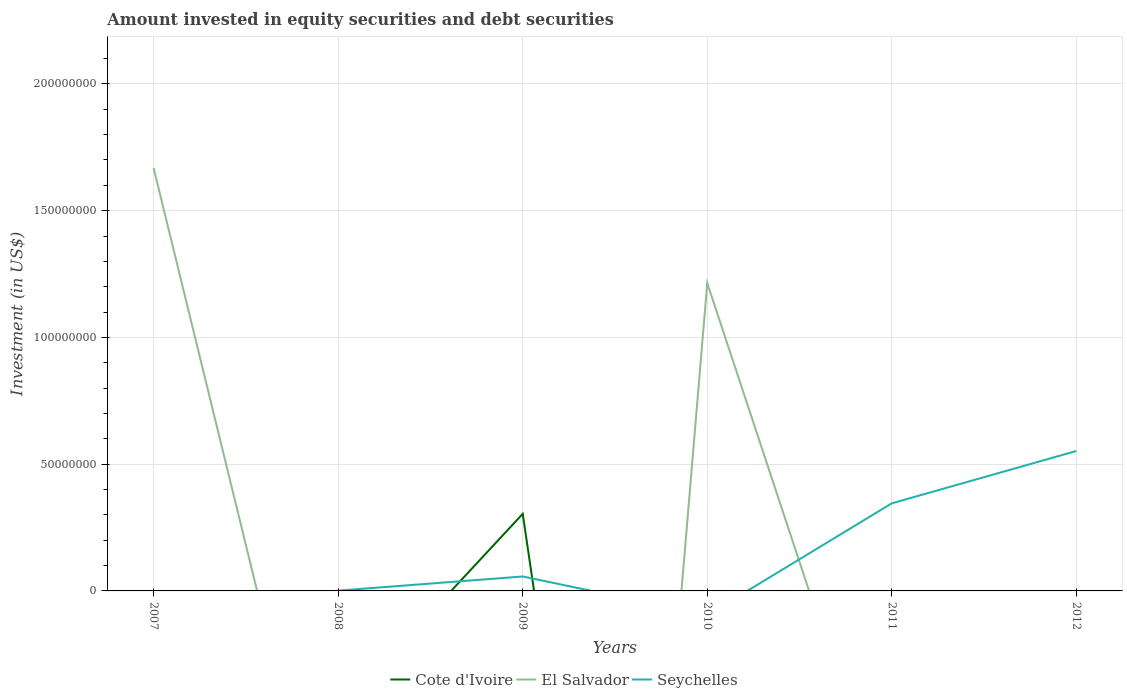How many different coloured lines are there?
Offer a very short reply. 3. Is the number of lines equal to the number of legend labels?
Give a very brief answer. No. Across all years, what is the maximum amount invested in equity securities and debt securities in Seychelles?
Ensure brevity in your answer.  0. What is the total amount invested in equity securities and debt securities in Seychelles in the graph?
Offer a terse response. -5.58e+06. What is the difference between the highest and the second highest amount invested in equity securities and debt securities in Cote d'Ivoire?
Keep it short and to the point. 3.04e+07. Is the amount invested in equity securities and debt securities in Cote d'Ivoire strictly greater than the amount invested in equity securities and debt securities in Seychelles over the years?
Your answer should be compact. No. How many years are there in the graph?
Offer a very short reply. 6. Are the values on the major ticks of Y-axis written in scientific E-notation?
Your answer should be compact. No. Where does the legend appear in the graph?
Provide a succinct answer. Bottom center. How are the legend labels stacked?
Ensure brevity in your answer.  Horizontal. What is the title of the graph?
Your answer should be very brief. Amount invested in equity securities and debt securities. What is the label or title of the Y-axis?
Give a very brief answer. Investment (in US$). What is the Investment (in US$) in El Salvador in 2007?
Offer a very short reply. 1.67e+08. What is the Investment (in US$) in Cote d'Ivoire in 2008?
Make the answer very short. 0. What is the Investment (in US$) in Seychelles in 2008?
Your response must be concise. 1.16e+05. What is the Investment (in US$) in Cote d'Ivoire in 2009?
Your answer should be very brief. 3.04e+07. What is the Investment (in US$) of Seychelles in 2009?
Your answer should be compact. 5.70e+06. What is the Investment (in US$) of El Salvador in 2010?
Offer a very short reply. 1.21e+08. What is the Investment (in US$) of Seychelles in 2010?
Offer a very short reply. 0. What is the Investment (in US$) of El Salvador in 2011?
Provide a succinct answer. 0. What is the Investment (in US$) of Seychelles in 2011?
Give a very brief answer. 3.46e+07. What is the Investment (in US$) in Cote d'Ivoire in 2012?
Keep it short and to the point. 0. What is the Investment (in US$) of El Salvador in 2012?
Make the answer very short. 0. What is the Investment (in US$) in Seychelles in 2012?
Your answer should be compact. 5.52e+07. Across all years, what is the maximum Investment (in US$) in Cote d'Ivoire?
Provide a succinct answer. 3.04e+07. Across all years, what is the maximum Investment (in US$) of El Salvador?
Offer a very short reply. 1.67e+08. Across all years, what is the maximum Investment (in US$) in Seychelles?
Provide a short and direct response. 5.52e+07. Across all years, what is the minimum Investment (in US$) of Cote d'Ivoire?
Offer a very short reply. 0. What is the total Investment (in US$) in Cote d'Ivoire in the graph?
Your response must be concise. 3.04e+07. What is the total Investment (in US$) in El Salvador in the graph?
Make the answer very short. 2.88e+08. What is the total Investment (in US$) in Seychelles in the graph?
Give a very brief answer. 9.56e+07. What is the difference between the Investment (in US$) of El Salvador in 2007 and that in 2010?
Keep it short and to the point. 4.54e+07. What is the difference between the Investment (in US$) in Seychelles in 2008 and that in 2009?
Give a very brief answer. -5.58e+06. What is the difference between the Investment (in US$) in Seychelles in 2008 and that in 2011?
Ensure brevity in your answer.  -3.44e+07. What is the difference between the Investment (in US$) of Seychelles in 2008 and that in 2012?
Offer a very short reply. -5.51e+07. What is the difference between the Investment (in US$) of Seychelles in 2009 and that in 2011?
Your answer should be very brief. -2.89e+07. What is the difference between the Investment (in US$) in Seychelles in 2009 and that in 2012?
Your answer should be compact. -4.95e+07. What is the difference between the Investment (in US$) in Seychelles in 2011 and that in 2012?
Your answer should be compact. -2.07e+07. What is the difference between the Investment (in US$) in El Salvador in 2007 and the Investment (in US$) in Seychelles in 2008?
Your response must be concise. 1.67e+08. What is the difference between the Investment (in US$) of El Salvador in 2007 and the Investment (in US$) of Seychelles in 2009?
Provide a succinct answer. 1.61e+08. What is the difference between the Investment (in US$) in El Salvador in 2007 and the Investment (in US$) in Seychelles in 2011?
Your answer should be very brief. 1.32e+08. What is the difference between the Investment (in US$) of El Salvador in 2007 and the Investment (in US$) of Seychelles in 2012?
Give a very brief answer. 1.12e+08. What is the difference between the Investment (in US$) in Cote d'Ivoire in 2009 and the Investment (in US$) in El Salvador in 2010?
Provide a succinct answer. -9.10e+07. What is the difference between the Investment (in US$) of Cote d'Ivoire in 2009 and the Investment (in US$) of Seychelles in 2011?
Give a very brief answer. -4.15e+06. What is the difference between the Investment (in US$) of Cote d'Ivoire in 2009 and the Investment (in US$) of Seychelles in 2012?
Your answer should be very brief. -2.48e+07. What is the difference between the Investment (in US$) in El Salvador in 2010 and the Investment (in US$) in Seychelles in 2011?
Your response must be concise. 8.68e+07. What is the difference between the Investment (in US$) of El Salvador in 2010 and the Investment (in US$) of Seychelles in 2012?
Keep it short and to the point. 6.62e+07. What is the average Investment (in US$) of Cote d'Ivoire per year?
Provide a short and direct response. 5.07e+06. What is the average Investment (in US$) in El Salvador per year?
Your answer should be very brief. 4.80e+07. What is the average Investment (in US$) in Seychelles per year?
Your response must be concise. 1.59e+07. In the year 2009, what is the difference between the Investment (in US$) in Cote d'Ivoire and Investment (in US$) in Seychelles?
Give a very brief answer. 2.47e+07. What is the ratio of the Investment (in US$) in El Salvador in 2007 to that in 2010?
Your answer should be very brief. 1.37. What is the ratio of the Investment (in US$) of Seychelles in 2008 to that in 2009?
Give a very brief answer. 0.02. What is the ratio of the Investment (in US$) of Seychelles in 2008 to that in 2011?
Your answer should be compact. 0. What is the ratio of the Investment (in US$) in Seychelles in 2008 to that in 2012?
Ensure brevity in your answer.  0. What is the ratio of the Investment (in US$) of Seychelles in 2009 to that in 2011?
Give a very brief answer. 0.16. What is the ratio of the Investment (in US$) in Seychelles in 2009 to that in 2012?
Keep it short and to the point. 0.1. What is the ratio of the Investment (in US$) in Seychelles in 2011 to that in 2012?
Give a very brief answer. 0.63. What is the difference between the highest and the second highest Investment (in US$) in Seychelles?
Keep it short and to the point. 2.07e+07. What is the difference between the highest and the lowest Investment (in US$) of Cote d'Ivoire?
Your response must be concise. 3.04e+07. What is the difference between the highest and the lowest Investment (in US$) of El Salvador?
Your answer should be compact. 1.67e+08. What is the difference between the highest and the lowest Investment (in US$) in Seychelles?
Your answer should be very brief. 5.52e+07. 